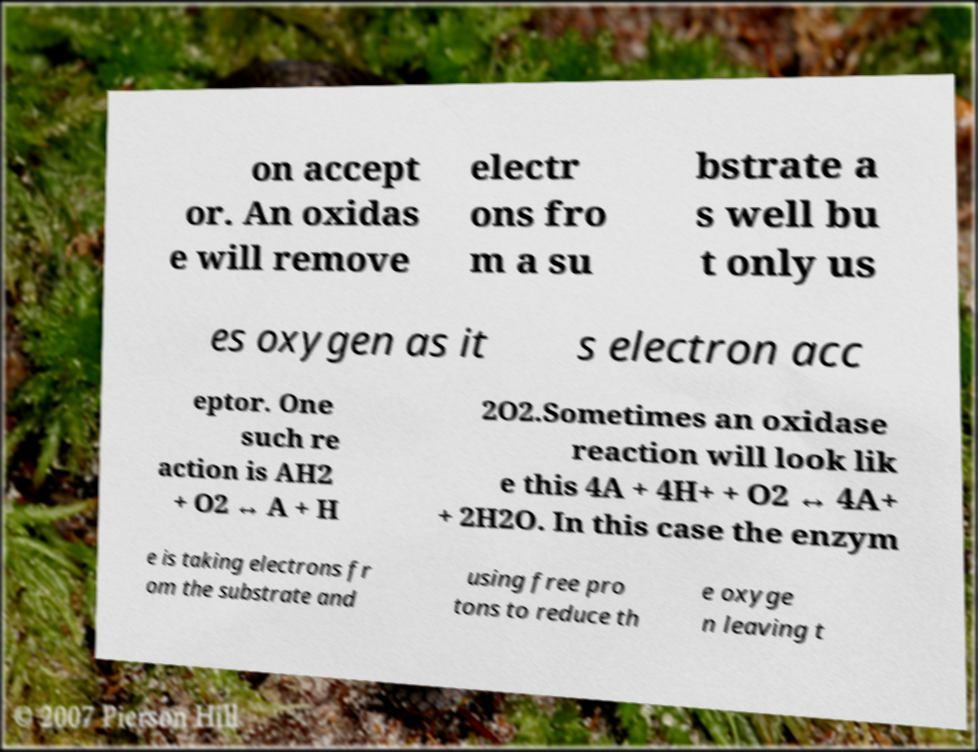For documentation purposes, I need the text within this image transcribed. Could you provide that? on accept or. An oxidas e will remove electr ons fro m a su bstrate a s well bu t only us es oxygen as it s electron acc eptor. One such re action is AH2 + O2 ↔ A + H 2O2.Sometimes an oxidase reaction will look lik e this 4A + 4H+ + O2 ↔ 4A+ + 2H2O. In this case the enzym e is taking electrons fr om the substrate and using free pro tons to reduce th e oxyge n leaving t 